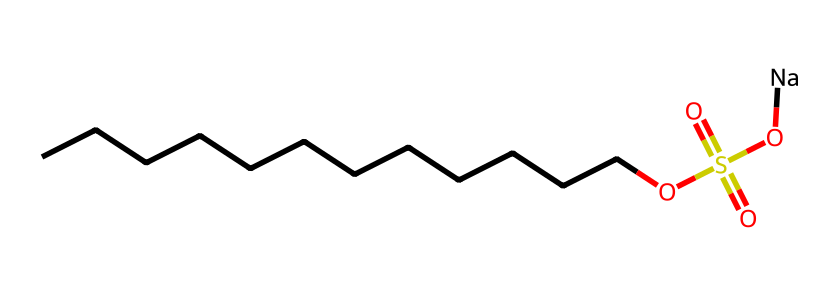how many carbon atoms are in the structure? By analyzing the SMILES representation, "CCCCCCCCCCCC" indicates a chain of 12 carbon atoms. Each 'C' represents one carbon atom.
Answer: 12 what is the function of the sulfonate group in this surfactant? The sulfonate group (OS(=O)(=O)O) serves as the hydrophilic (water-attracting) part of the molecule, which helps in reducing surface tension and aids in wetting surfaces.
Answer: hydrophilic how many oxygen atoms are present in this surfactant? In the structure, counting the oxygen atoms yields a total of 4: one from the sulfonate group and three from the -OS(=O)(=O)O group.
Answer: 4 what type of chemical functional group is present at the end of this structure? The structure ends with a sulfonic acid group (-OS(=O)(=O)O), characterized by the presence of sulfur and oxygen, making it a sulfonate.
Answer: sulfonate what property is primarily associated with the long hydrocarbon chain of this surfactant? The long hydrocarbon chain (CCCCCCCCCCCC) is responsible for the hydrophobic (water-repelling) property of the surfactant, allowing it to interact with oils and grease.
Answer: hydrophobic what is the charge of the sodium in this surfactant? The sodium (Na) in the structure is typically ionized with a positive charge, balancing the negatively charged sulfonate group.
Answer: positive what role does sodium play in this surfactant? Sodium acts as a counterion to the sulfonate group, helping to stabilize the surfactant in solution and enhancing its solubility in water.
Answer: stabilizing agent 